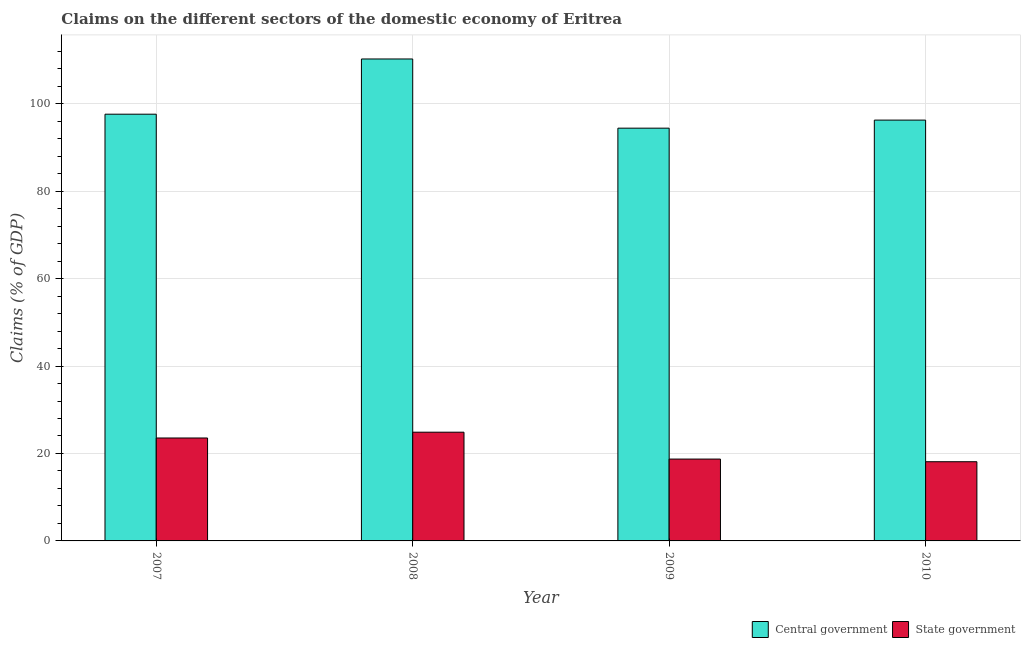Are the number of bars per tick equal to the number of legend labels?
Provide a succinct answer. Yes. Are the number of bars on each tick of the X-axis equal?
Your answer should be compact. Yes. How many bars are there on the 4th tick from the right?
Provide a short and direct response. 2. What is the label of the 4th group of bars from the left?
Provide a succinct answer. 2010. What is the claims on state government in 2007?
Offer a terse response. 23.54. Across all years, what is the maximum claims on state government?
Give a very brief answer. 24.87. Across all years, what is the minimum claims on state government?
Give a very brief answer. 18.11. In which year was the claims on central government maximum?
Your answer should be compact. 2008. In which year was the claims on state government minimum?
Your answer should be compact. 2010. What is the total claims on state government in the graph?
Offer a very short reply. 85.25. What is the difference between the claims on central government in 2007 and that in 2009?
Ensure brevity in your answer.  3.2. What is the difference between the claims on state government in 2008 and the claims on central government in 2007?
Ensure brevity in your answer.  1.33. What is the average claims on central government per year?
Your answer should be very brief. 99.62. What is the ratio of the claims on state government in 2007 to that in 2010?
Offer a very short reply. 1.3. Is the claims on central government in 2008 less than that in 2010?
Provide a short and direct response. No. What is the difference between the highest and the second highest claims on state government?
Make the answer very short. 1.33. What is the difference between the highest and the lowest claims on state government?
Make the answer very short. 6.76. What does the 1st bar from the left in 2008 represents?
Ensure brevity in your answer.  Central government. What does the 2nd bar from the right in 2007 represents?
Ensure brevity in your answer.  Central government. Are all the bars in the graph horizontal?
Provide a short and direct response. No. How many years are there in the graph?
Your answer should be very brief. 4. Does the graph contain any zero values?
Your answer should be very brief. No. How many legend labels are there?
Your answer should be very brief. 2. How are the legend labels stacked?
Keep it short and to the point. Horizontal. What is the title of the graph?
Your answer should be very brief. Claims on the different sectors of the domestic economy of Eritrea. What is the label or title of the X-axis?
Keep it short and to the point. Year. What is the label or title of the Y-axis?
Make the answer very short. Claims (% of GDP). What is the Claims (% of GDP) in Central government in 2007?
Offer a very short reply. 97.6. What is the Claims (% of GDP) of State government in 2007?
Make the answer very short. 23.54. What is the Claims (% of GDP) in Central government in 2008?
Offer a very short reply. 110.23. What is the Claims (% of GDP) of State government in 2008?
Your response must be concise. 24.87. What is the Claims (% of GDP) in Central government in 2009?
Provide a short and direct response. 94.4. What is the Claims (% of GDP) in State government in 2009?
Give a very brief answer. 18.72. What is the Claims (% of GDP) in Central government in 2010?
Keep it short and to the point. 96.25. What is the Claims (% of GDP) in State government in 2010?
Provide a succinct answer. 18.11. Across all years, what is the maximum Claims (% of GDP) of Central government?
Give a very brief answer. 110.23. Across all years, what is the maximum Claims (% of GDP) of State government?
Offer a terse response. 24.87. Across all years, what is the minimum Claims (% of GDP) of Central government?
Your answer should be compact. 94.4. Across all years, what is the minimum Claims (% of GDP) of State government?
Give a very brief answer. 18.11. What is the total Claims (% of GDP) of Central government in the graph?
Offer a very short reply. 398.48. What is the total Claims (% of GDP) in State government in the graph?
Your response must be concise. 85.25. What is the difference between the Claims (% of GDP) of Central government in 2007 and that in 2008?
Ensure brevity in your answer.  -12.63. What is the difference between the Claims (% of GDP) in State government in 2007 and that in 2008?
Your answer should be very brief. -1.33. What is the difference between the Claims (% of GDP) in Central government in 2007 and that in 2009?
Offer a terse response. 3.2. What is the difference between the Claims (% of GDP) in State government in 2007 and that in 2009?
Provide a short and direct response. 4.82. What is the difference between the Claims (% of GDP) in Central government in 2007 and that in 2010?
Give a very brief answer. 1.35. What is the difference between the Claims (% of GDP) in State government in 2007 and that in 2010?
Your answer should be compact. 5.43. What is the difference between the Claims (% of GDP) in Central government in 2008 and that in 2009?
Your answer should be compact. 15.83. What is the difference between the Claims (% of GDP) in State government in 2008 and that in 2009?
Give a very brief answer. 6.15. What is the difference between the Claims (% of GDP) of Central government in 2008 and that in 2010?
Ensure brevity in your answer.  13.98. What is the difference between the Claims (% of GDP) in State government in 2008 and that in 2010?
Your answer should be compact. 6.76. What is the difference between the Claims (% of GDP) in Central government in 2009 and that in 2010?
Ensure brevity in your answer.  -1.84. What is the difference between the Claims (% of GDP) in State government in 2009 and that in 2010?
Make the answer very short. 0.61. What is the difference between the Claims (% of GDP) in Central government in 2007 and the Claims (% of GDP) in State government in 2008?
Provide a succinct answer. 72.73. What is the difference between the Claims (% of GDP) of Central government in 2007 and the Claims (% of GDP) of State government in 2009?
Provide a succinct answer. 78.88. What is the difference between the Claims (% of GDP) of Central government in 2007 and the Claims (% of GDP) of State government in 2010?
Offer a terse response. 79.49. What is the difference between the Claims (% of GDP) in Central government in 2008 and the Claims (% of GDP) in State government in 2009?
Provide a short and direct response. 91.51. What is the difference between the Claims (% of GDP) in Central government in 2008 and the Claims (% of GDP) in State government in 2010?
Keep it short and to the point. 92.12. What is the difference between the Claims (% of GDP) of Central government in 2009 and the Claims (% of GDP) of State government in 2010?
Make the answer very short. 76.29. What is the average Claims (% of GDP) of Central government per year?
Provide a short and direct response. 99.62. What is the average Claims (% of GDP) in State government per year?
Provide a short and direct response. 21.31. In the year 2007, what is the difference between the Claims (% of GDP) in Central government and Claims (% of GDP) in State government?
Ensure brevity in your answer.  74.06. In the year 2008, what is the difference between the Claims (% of GDP) of Central government and Claims (% of GDP) of State government?
Your answer should be very brief. 85.36. In the year 2009, what is the difference between the Claims (% of GDP) in Central government and Claims (% of GDP) in State government?
Provide a short and direct response. 75.68. In the year 2010, what is the difference between the Claims (% of GDP) of Central government and Claims (% of GDP) of State government?
Give a very brief answer. 78.14. What is the ratio of the Claims (% of GDP) in Central government in 2007 to that in 2008?
Your response must be concise. 0.89. What is the ratio of the Claims (% of GDP) of State government in 2007 to that in 2008?
Offer a terse response. 0.95. What is the ratio of the Claims (% of GDP) in Central government in 2007 to that in 2009?
Ensure brevity in your answer.  1.03. What is the ratio of the Claims (% of GDP) in State government in 2007 to that in 2009?
Provide a short and direct response. 1.26. What is the ratio of the Claims (% of GDP) of Central government in 2007 to that in 2010?
Ensure brevity in your answer.  1.01. What is the ratio of the Claims (% of GDP) in State government in 2007 to that in 2010?
Ensure brevity in your answer.  1.3. What is the ratio of the Claims (% of GDP) in Central government in 2008 to that in 2009?
Your answer should be compact. 1.17. What is the ratio of the Claims (% of GDP) in State government in 2008 to that in 2009?
Your answer should be very brief. 1.33. What is the ratio of the Claims (% of GDP) of Central government in 2008 to that in 2010?
Your response must be concise. 1.15. What is the ratio of the Claims (% of GDP) in State government in 2008 to that in 2010?
Keep it short and to the point. 1.37. What is the ratio of the Claims (% of GDP) of Central government in 2009 to that in 2010?
Make the answer very short. 0.98. What is the ratio of the Claims (% of GDP) in State government in 2009 to that in 2010?
Provide a short and direct response. 1.03. What is the difference between the highest and the second highest Claims (% of GDP) of Central government?
Make the answer very short. 12.63. What is the difference between the highest and the second highest Claims (% of GDP) in State government?
Your answer should be compact. 1.33. What is the difference between the highest and the lowest Claims (% of GDP) in Central government?
Ensure brevity in your answer.  15.83. What is the difference between the highest and the lowest Claims (% of GDP) in State government?
Offer a terse response. 6.76. 